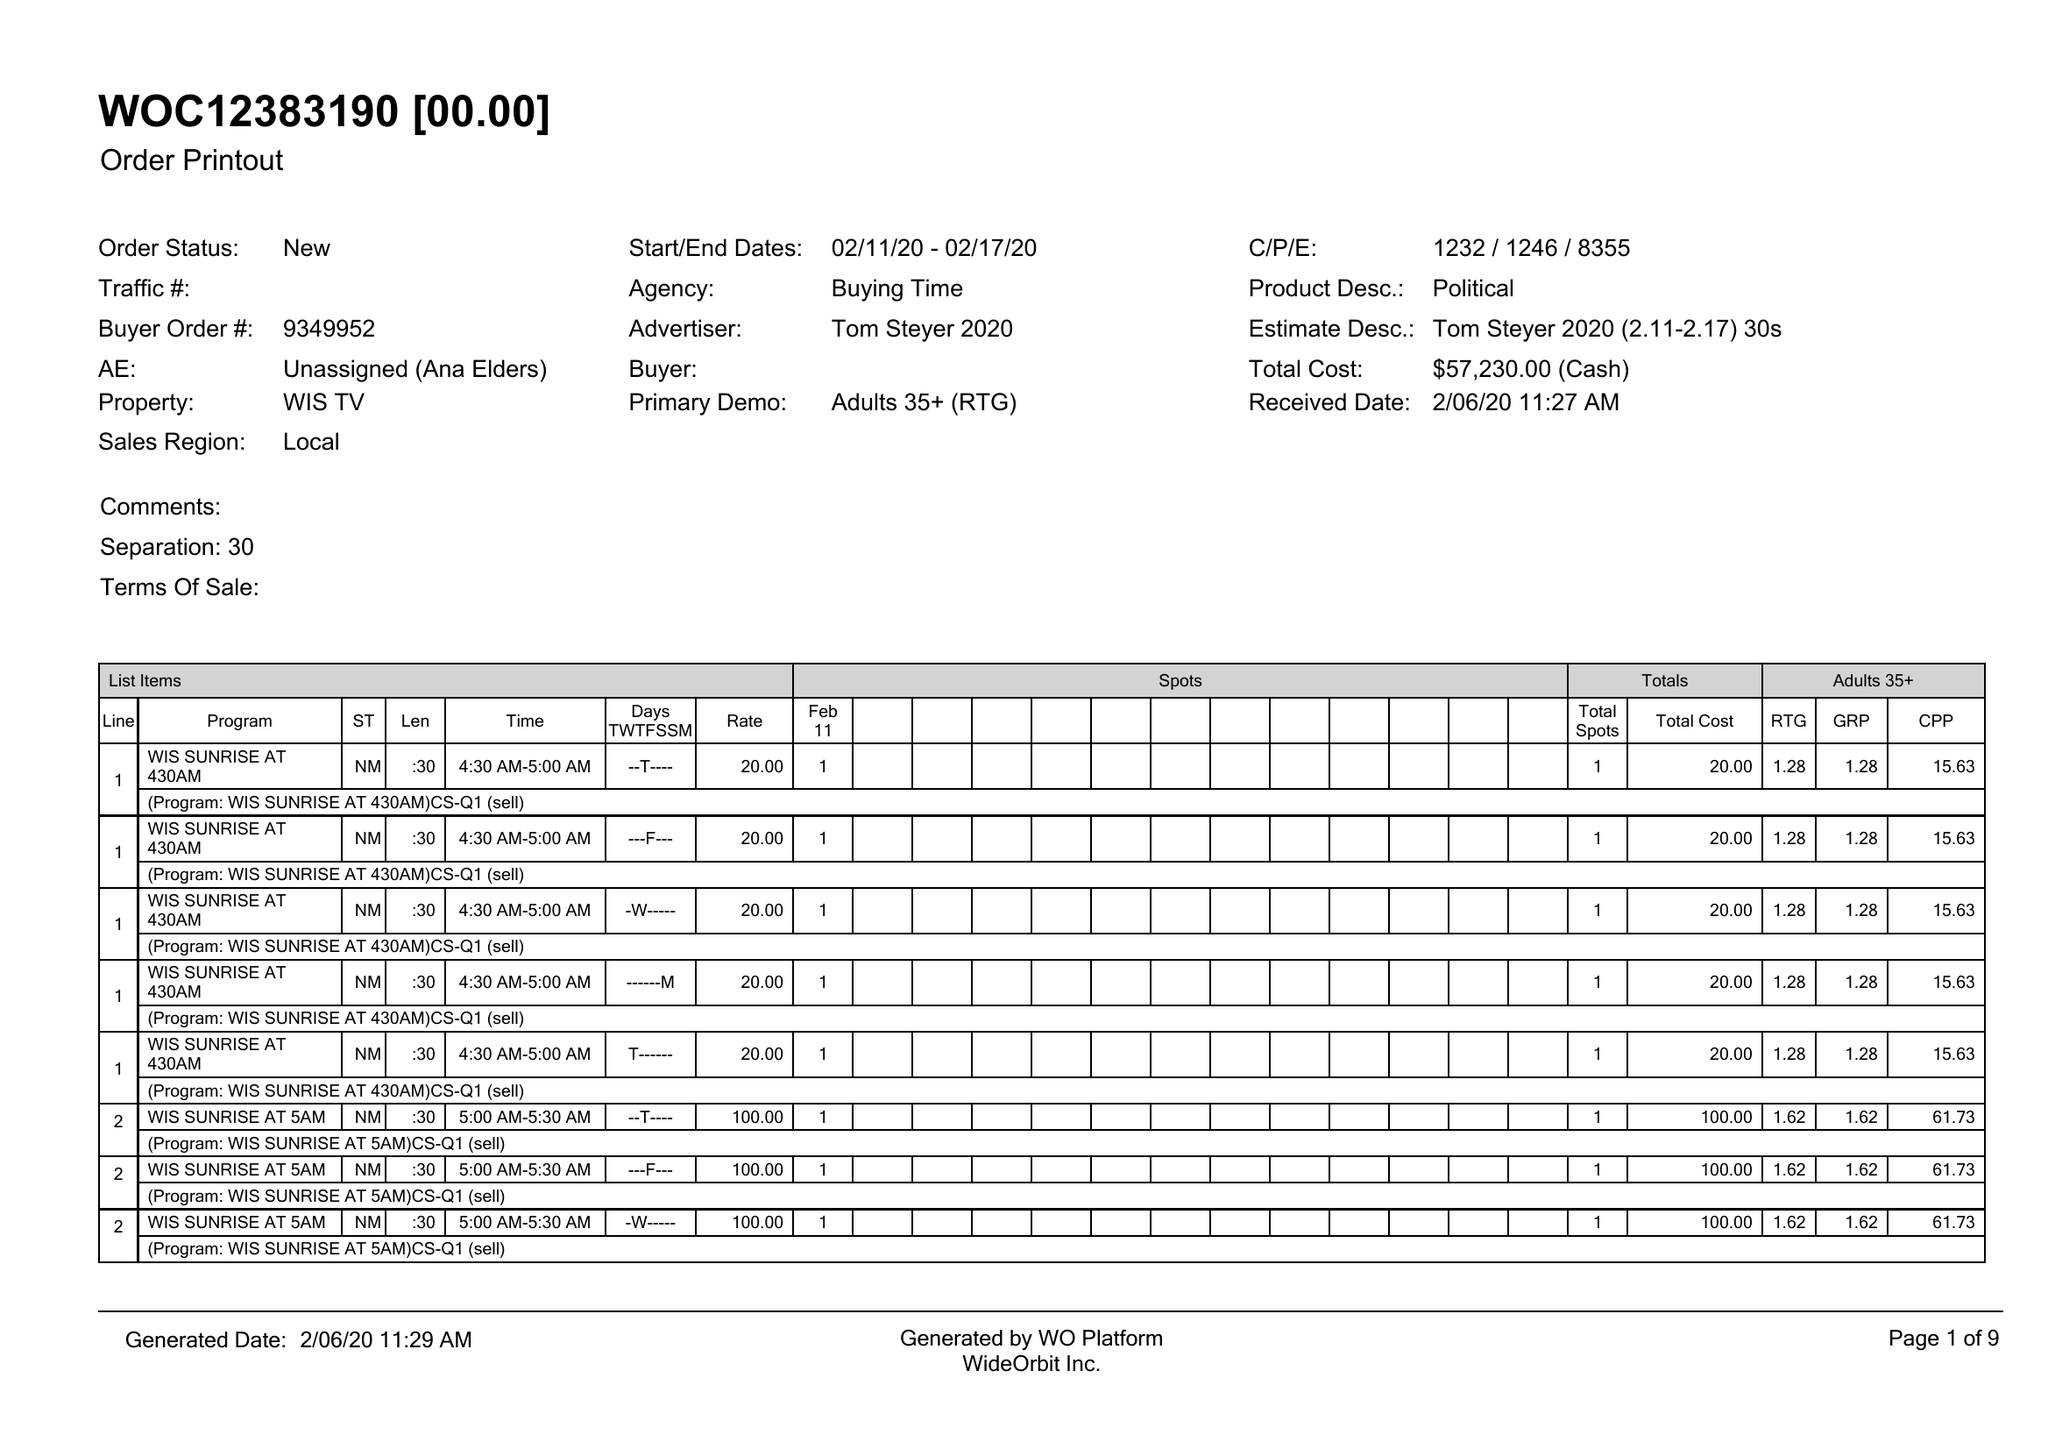What is the value for the gross_amount?
Answer the question using a single word or phrase. 57230.00 